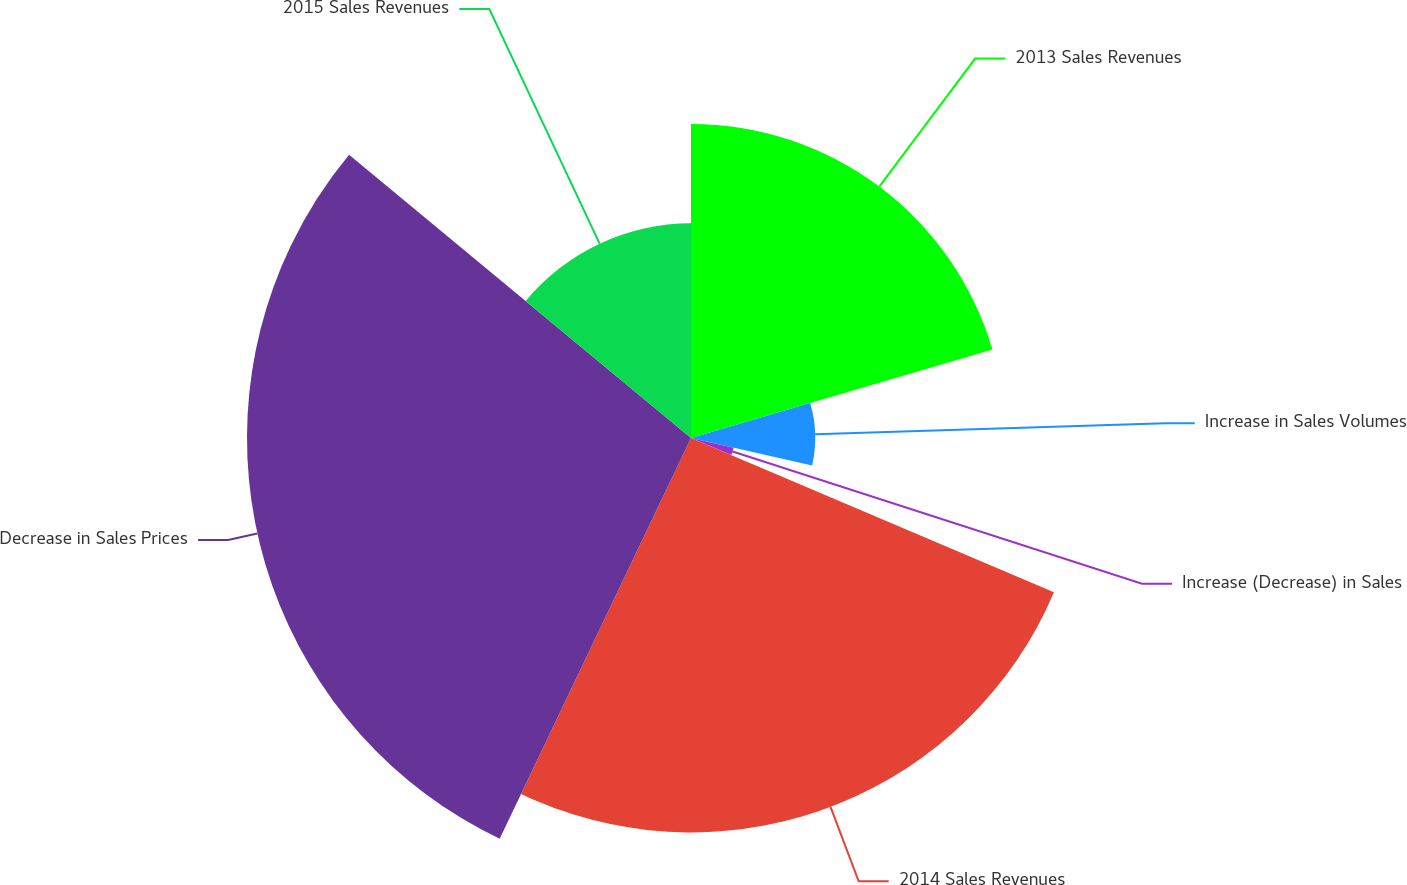<chart> <loc_0><loc_0><loc_500><loc_500><pie_chart><fcel>2013 Sales Revenues<fcel>Increase in Sales Volumes<fcel>Increase (Decrease) in Sales<fcel>2014 Sales Revenues<fcel>Decrease in Sales Prices<fcel>2015 Sales Revenues<nl><fcel>20.46%<fcel>8.09%<fcel>2.85%<fcel>25.69%<fcel>28.92%<fcel>13.99%<nl></chart> 